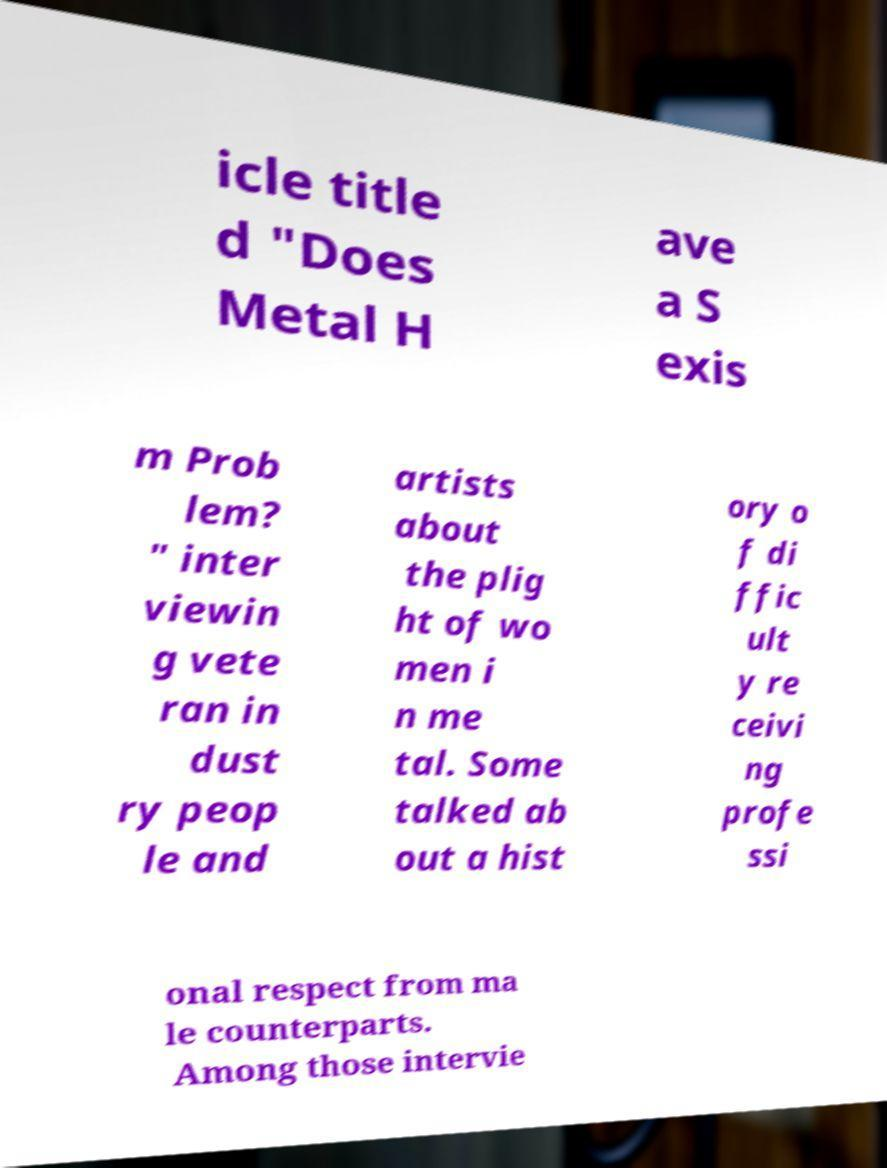For documentation purposes, I need the text within this image transcribed. Could you provide that? icle title d "Does Metal H ave a S exis m Prob lem? " inter viewin g vete ran in dust ry peop le and artists about the plig ht of wo men i n me tal. Some talked ab out a hist ory o f di ffic ult y re ceivi ng profe ssi onal respect from ma le counterparts. Among those intervie 